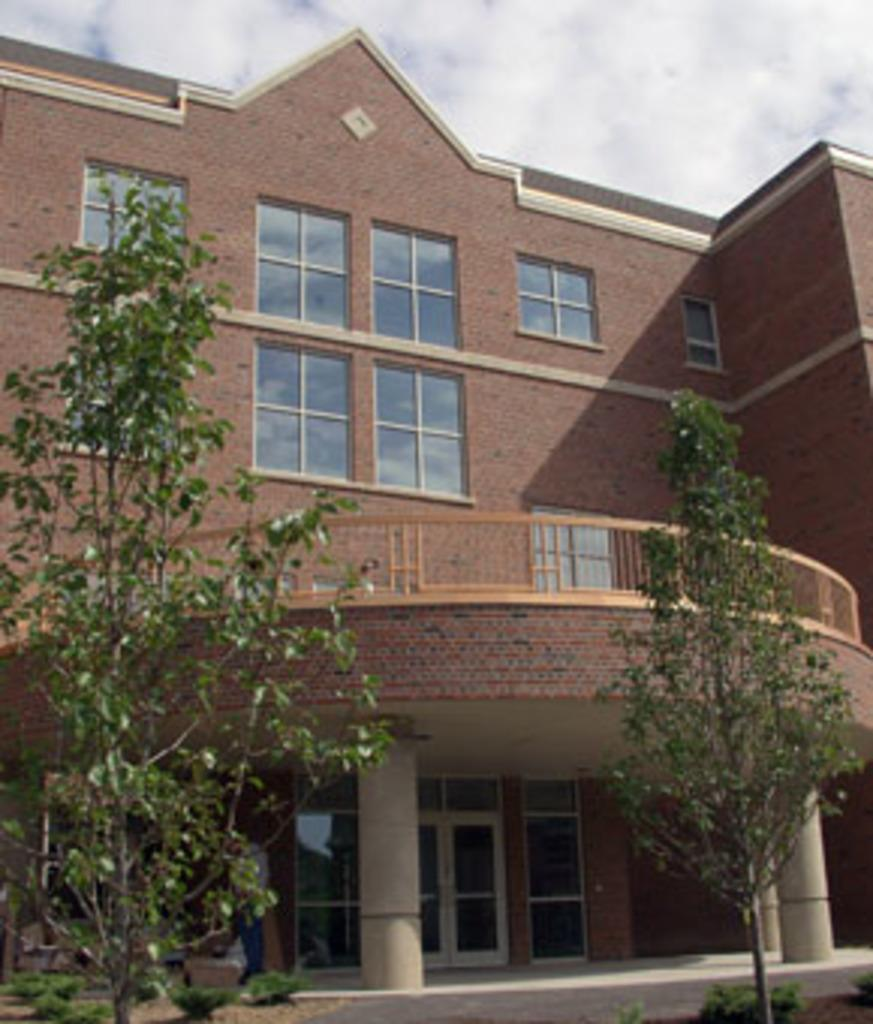What is the main structure in the image? There is a building in the image. What feature can be seen on the building? The building has windows. What type of vegetation is in front of the building? There are trees in front of the building. What is visible in the sky at the top of the image? There are clouds visible in the sky at the top of the image. What shape is the pickle on the street in the image? There is no pickle or street present in the image. How many streetlights are visible on the street in the image? There is no street or streetlights present in the image. 